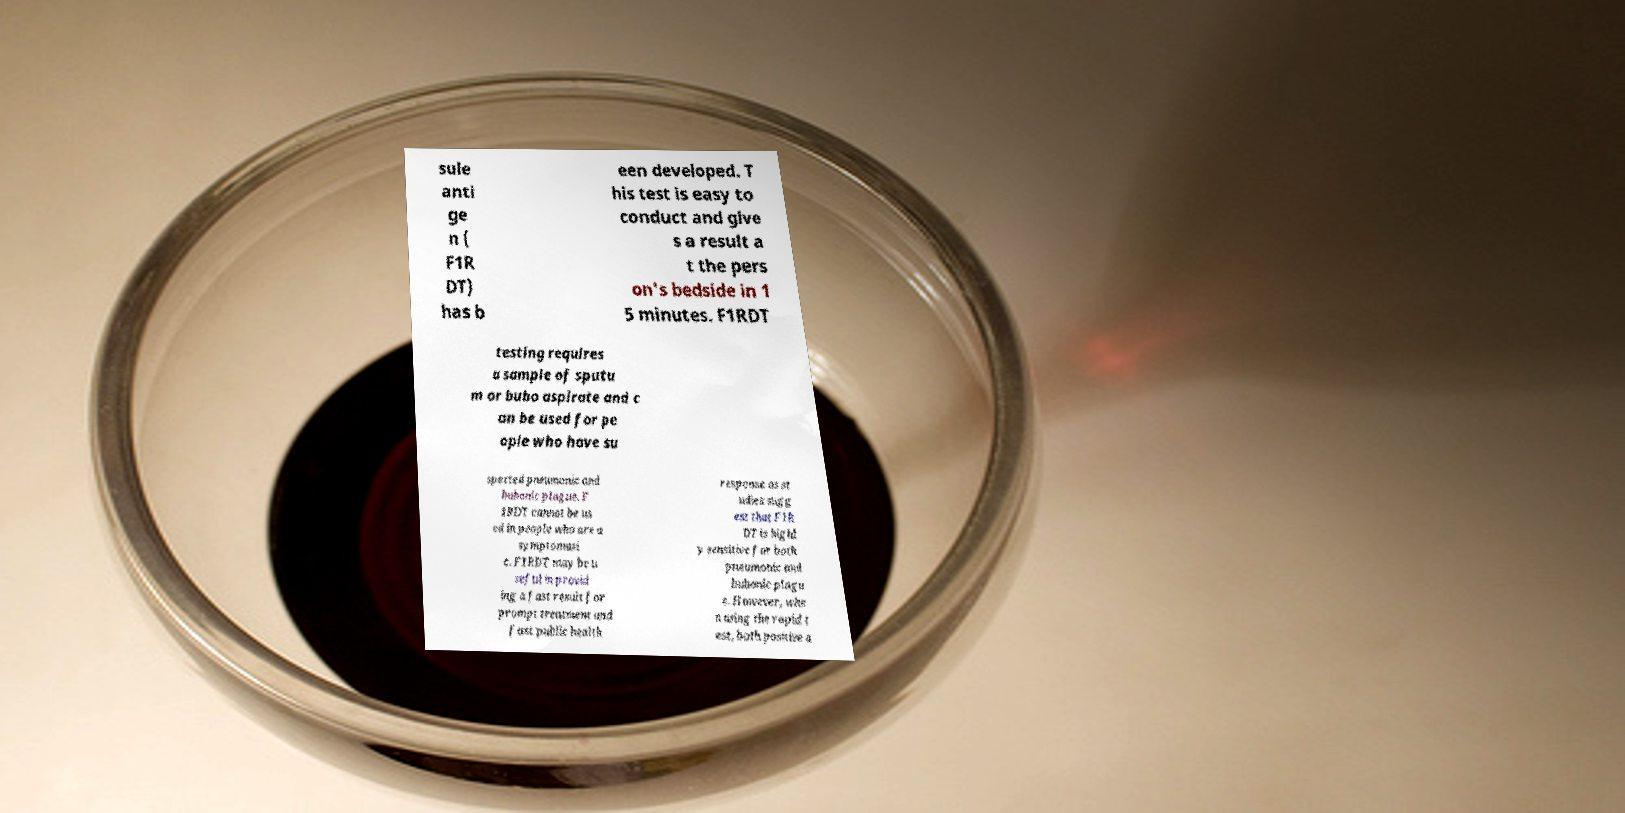For documentation purposes, I need the text within this image transcribed. Could you provide that? sule anti ge n ( F1R DT) has b een developed. T his test is easy to conduct and give s a result a t the pers on's bedside in 1 5 minutes. F1RDT testing requires a sample of sputu m or bubo aspirate and c an be used for pe ople who have su spected pneumonic and bubonic plague. F 1RDT cannot be us ed in people who are a symptomati c. F1RDT may be u seful in provid ing a fast result for prompt treatment and fast public health response as st udies sugg est that F1R DT is highl y sensitive for both pneumonic and bubonic plagu e. However, whe n using the rapid t est, both positive a 